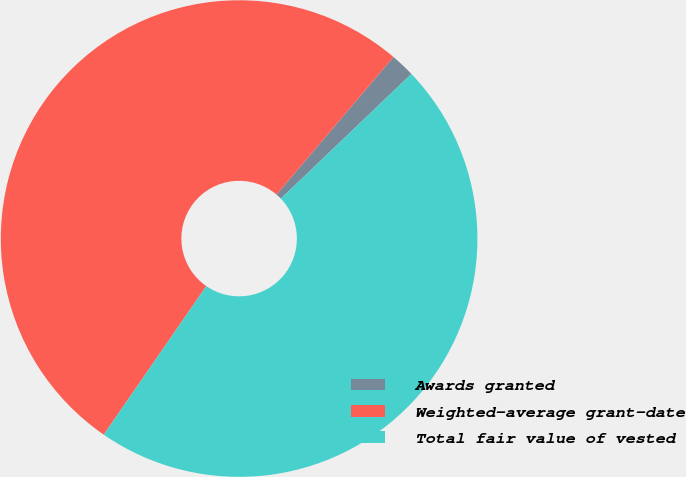<chart> <loc_0><loc_0><loc_500><loc_500><pie_chart><fcel>Awards granted<fcel>Weighted-average grant-date<fcel>Total fair value of vested<nl><fcel>1.65%<fcel>51.59%<fcel>46.75%<nl></chart> 